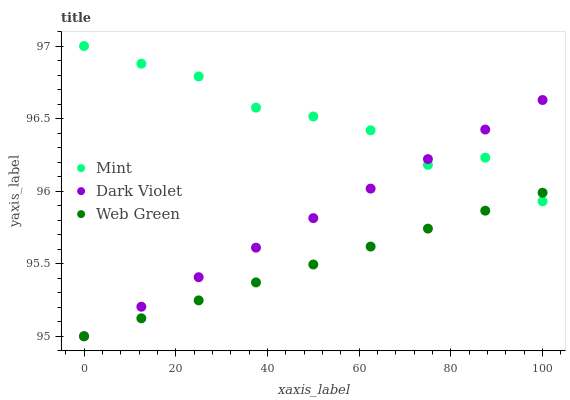Does Web Green have the minimum area under the curve?
Answer yes or no. Yes. Does Mint have the maximum area under the curve?
Answer yes or no. Yes. Does Dark Violet have the minimum area under the curve?
Answer yes or no. No. Does Dark Violet have the maximum area under the curve?
Answer yes or no. No. Is Dark Violet the smoothest?
Answer yes or no. Yes. Is Mint the roughest?
Answer yes or no. Yes. Is Web Green the smoothest?
Answer yes or no. No. Is Web Green the roughest?
Answer yes or no. No. Does Web Green have the lowest value?
Answer yes or no. Yes. Does Mint have the highest value?
Answer yes or no. Yes. Does Dark Violet have the highest value?
Answer yes or no. No. Does Mint intersect Web Green?
Answer yes or no. Yes. Is Mint less than Web Green?
Answer yes or no. No. Is Mint greater than Web Green?
Answer yes or no. No. 